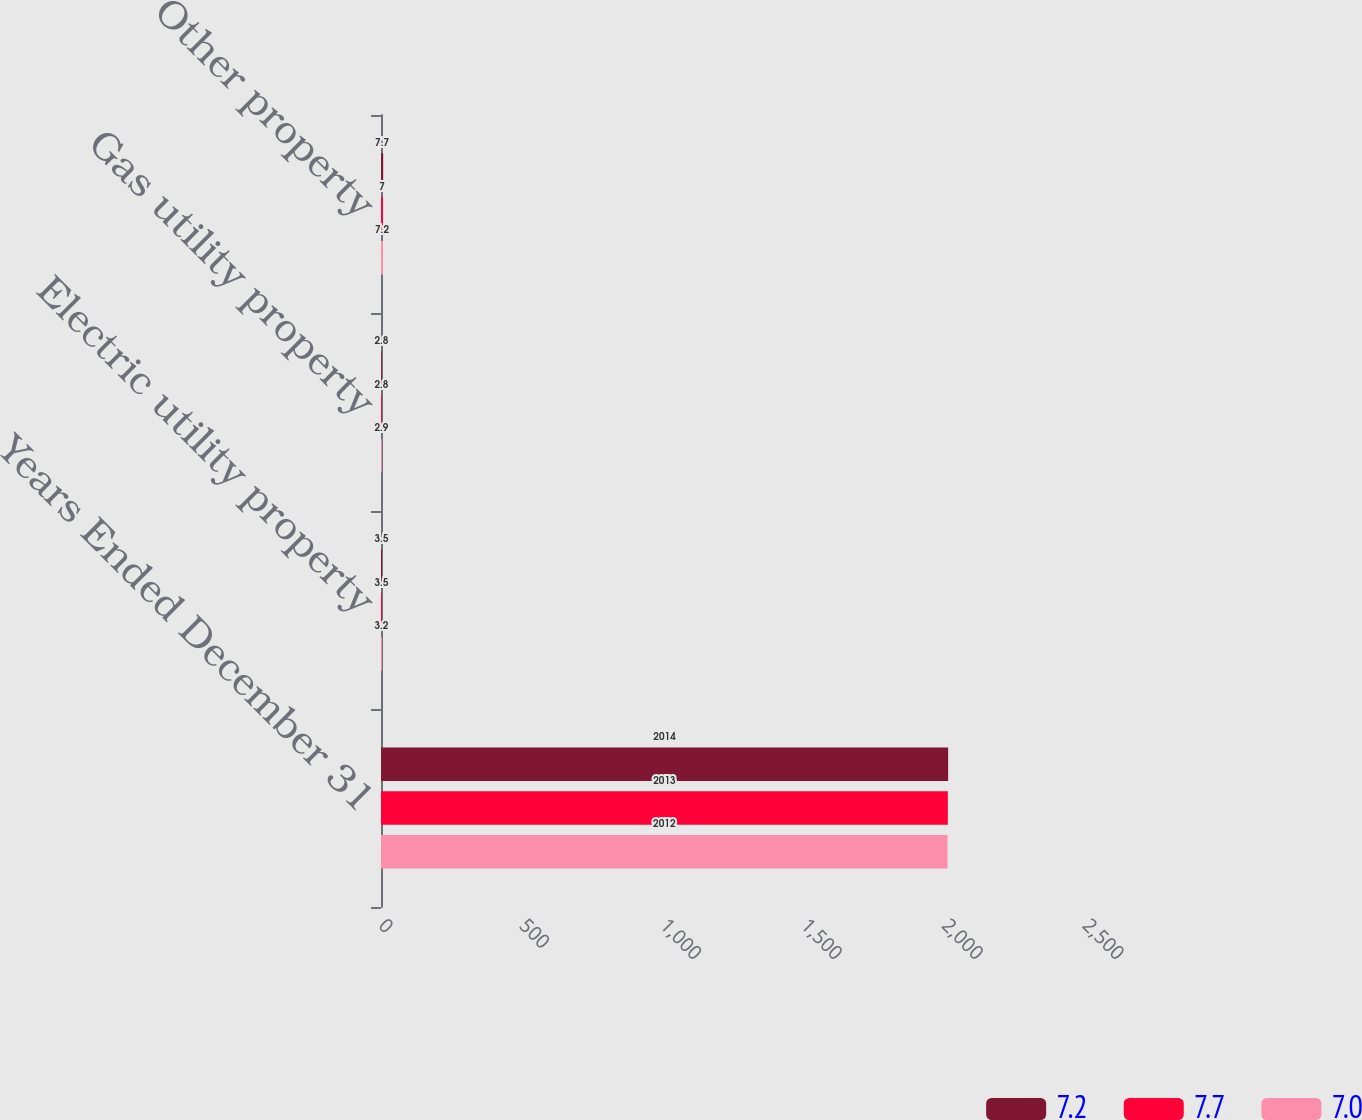Convert chart. <chart><loc_0><loc_0><loc_500><loc_500><stacked_bar_chart><ecel><fcel>Years Ended December 31<fcel>Electric utility property<fcel>Gas utility property<fcel>Other property<nl><fcel>7.2<fcel>2014<fcel>3.5<fcel>2.8<fcel>7.7<nl><fcel>7.7<fcel>2013<fcel>3.5<fcel>2.8<fcel>7<nl><fcel>7<fcel>2012<fcel>3.2<fcel>2.9<fcel>7.2<nl></chart> 